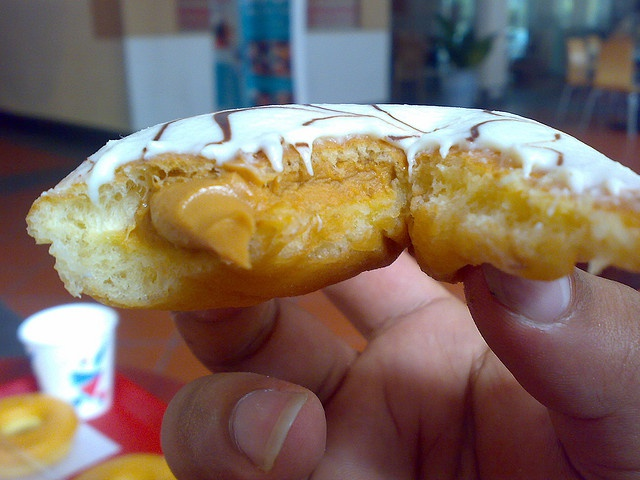Describe the objects in this image and their specific colors. I can see donut in gray, lightblue, tan, olive, and darkgray tones, people in gray, maroon, brown, and darkgray tones, cup in gray, white, lightblue, darkgray, and violet tones, donut in gray, tan, and orange tones, and chair in gray and darkblue tones in this image. 